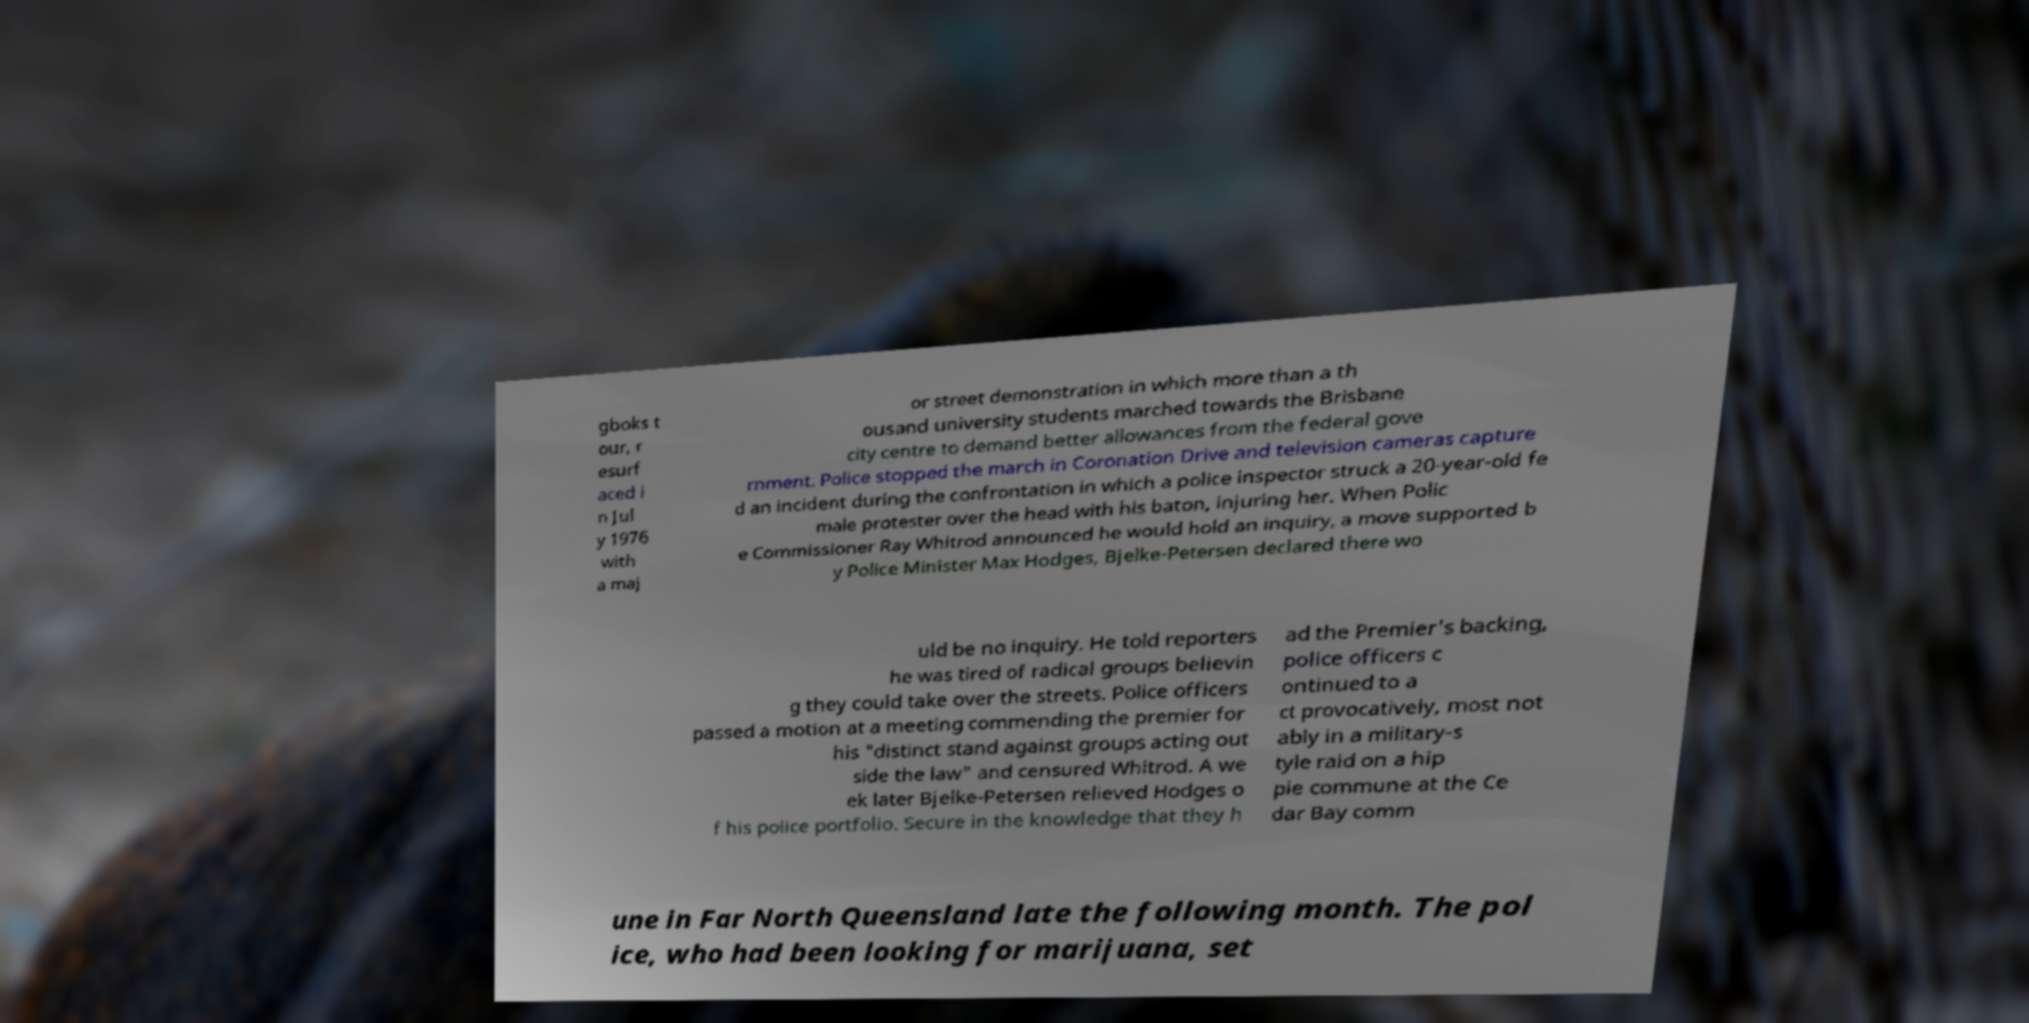Could you assist in decoding the text presented in this image and type it out clearly? gboks t our, r esurf aced i n Jul y 1976 with a maj or street demonstration in which more than a th ousand university students marched towards the Brisbane city centre to demand better allowances from the federal gove rnment. Police stopped the march in Coronation Drive and television cameras capture d an incident during the confrontation in which a police inspector struck a 20-year-old fe male protester over the head with his baton, injuring her. When Polic e Commissioner Ray Whitrod announced he would hold an inquiry, a move supported b y Police Minister Max Hodges, Bjelke-Petersen declared there wo uld be no inquiry. He told reporters he was tired of radical groups believin g they could take over the streets. Police officers passed a motion at a meeting commending the premier for his "distinct stand against groups acting out side the law" and censured Whitrod. A we ek later Bjelke-Petersen relieved Hodges o f his police portfolio. Secure in the knowledge that they h ad the Premier's backing, police officers c ontinued to a ct provocatively, most not ably in a military-s tyle raid on a hip pie commune at the Ce dar Bay comm une in Far North Queensland late the following month. The pol ice, who had been looking for marijuana, set 